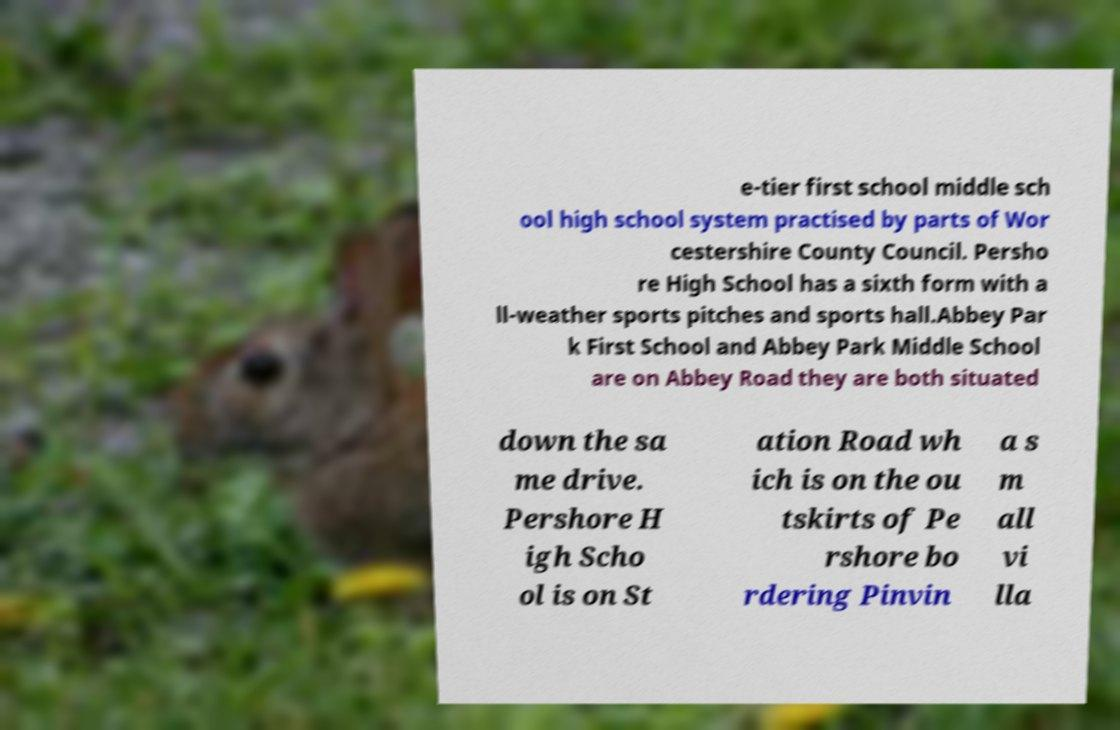What messages or text are displayed in this image? I need them in a readable, typed format. e-tier first school middle sch ool high school system practised by parts of Wor cestershire County Council. Persho re High School has a sixth form with a ll-weather sports pitches and sports hall.Abbey Par k First School and Abbey Park Middle School are on Abbey Road they are both situated down the sa me drive. Pershore H igh Scho ol is on St ation Road wh ich is on the ou tskirts of Pe rshore bo rdering Pinvin a s m all vi lla 